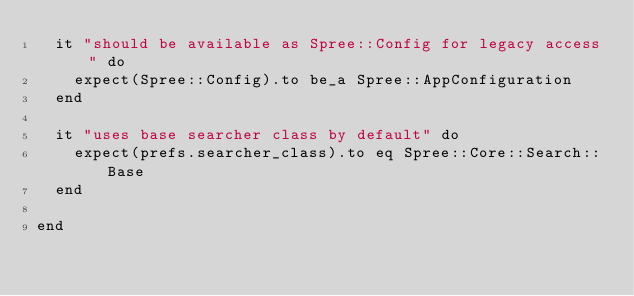<code> <loc_0><loc_0><loc_500><loc_500><_Ruby_>  it "should be available as Spree::Config for legacy access" do
    expect(Spree::Config).to be_a Spree::AppConfiguration
  end

  it "uses base searcher class by default" do
    expect(prefs.searcher_class).to eq Spree::Core::Search::Base
  end

end
</code> 